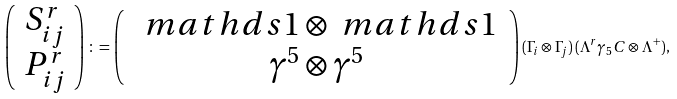Convert formula to latex. <formula><loc_0><loc_0><loc_500><loc_500>\left ( \begin{array} { c } S _ { i j } ^ { r } \\ P _ { i j } ^ { r } \end{array} \right ) \colon = \left ( \begin{array} { c } \, \ m a t h d s { 1 } \otimes \ m a t h d s { 1 } \, \\ \, \gamma ^ { 5 } \otimes \gamma ^ { 5 } \, \end{array} \right ) ( \Gamma _ { i } \otimes \Gamma _ { j } ) \, ( \Lambda ^ { r } \gamma _ { 5 } C \otimes \Lambda ^ { + } ) ,</formula> 